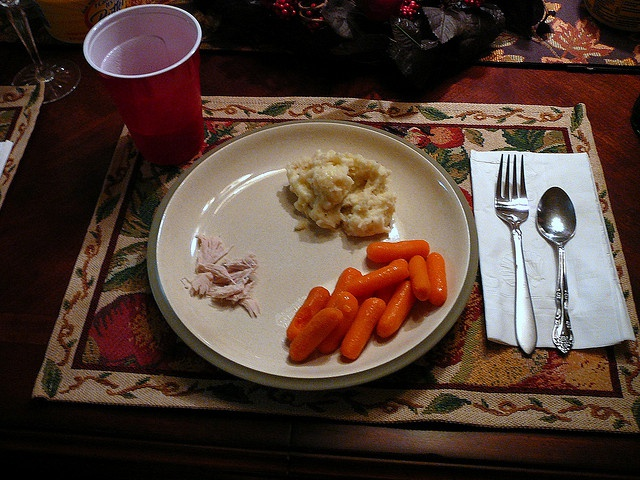Describe the objects in this image and their specific colors. I can see dining table in black, maroon, darkgray, and olive tones, cup in black, purple, and maroon tones, carrot in black, brown, maroon, and red tones, fork in black, white, gray, and darkgray tones, and spoon in black, gray, white, and darkgray tones in this image. 